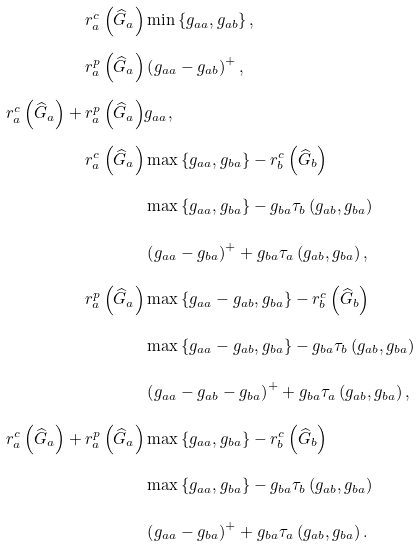<formula> <loc_0><loc_0><loc_500><loc_500>r _ { a } ^ { c } \left ( \widehat { G } _ { a } \right ) & \min \left \{ g _ { a a } , g _ { a b } \right \} , \\ r _ { a } ^ { p } \left ( \widehat { G } _ { a } \right ) & \left ( g _ { a a } - g _ { a b } \right ) ^ { + } , \\ r _ { a } ^ { c } \left ( \widehat { G } _ { a } \right ) + r _ { a } ^ { p } \left ( \widehat { G } _ { a } \right ) & g _ { a a } , \\ r _ { a } ^ { c } \left ( \widehat { G } _ { a } \right ) & \max \left \{ g _ { a a } , g _ { b a } \right \} - r _ { b } ^ { c } \left ( \widehat { G } _ { b } \right ) \\ & \max \left \{ g _ { a a } , g _ { b a } \right \} - g _ { b a } \tau _ { b } \left ( g _ { a b } , g _ { b a } \right ) \\ & \left ( g _ { a a } - g _ { b a } \right ) ^ { + } + g _ { b a } \tau _ { a } \left ( g _ { a b } , g _ { b a } \right ) , \\ r _ { a } ^ { p } \left ( \widehat { G } _ { a } \right ) & \max \left \{ g _ { a a } - g _ { a b } , g _ { b a } \right \} - r _ { b } ^ { c } \left ( \widehat { G } _ { b } \right ) \\ & \max \left \{ g _ { a a } - g _ { a b } , g _ { b a } \right \} - g _ { b a } \tau _ { b } \left ( g _ { a b } , g _ { b a } \right ) \\ & \left ( g _ { a a } - g _ { a b } - g _ { b a } \right ) ^ { + } + g _ { b a } \tau _ { a } \left ( g _ { a b } , g _ { b a } \right ) , \\ r _ { a } ^ { c } \left ( \widehat { G } _ { a } \right ) + r _ { a } ^ { p } \left ( \widehat { G } _ { a } \right ) & \max \left \{ g _ { a a } , g _ { b a } \right \} - r _ { b } ^ { c } \left ( \widehat { G } _ { b } \right ) \\ & \max \left \{ g _ { a a } , g _ { b a } \right \} - g _ { b a } \tau _ { b } \left ( g _ { a b } , g _ { b a } \right ) \\ & \left ( g _ { a a } - g _ { b a } \right ) ^ { + } + g _ { b a } \tau _ { a } \left ( g _ { a b } , g _ { b a } \right ) .</formula> 